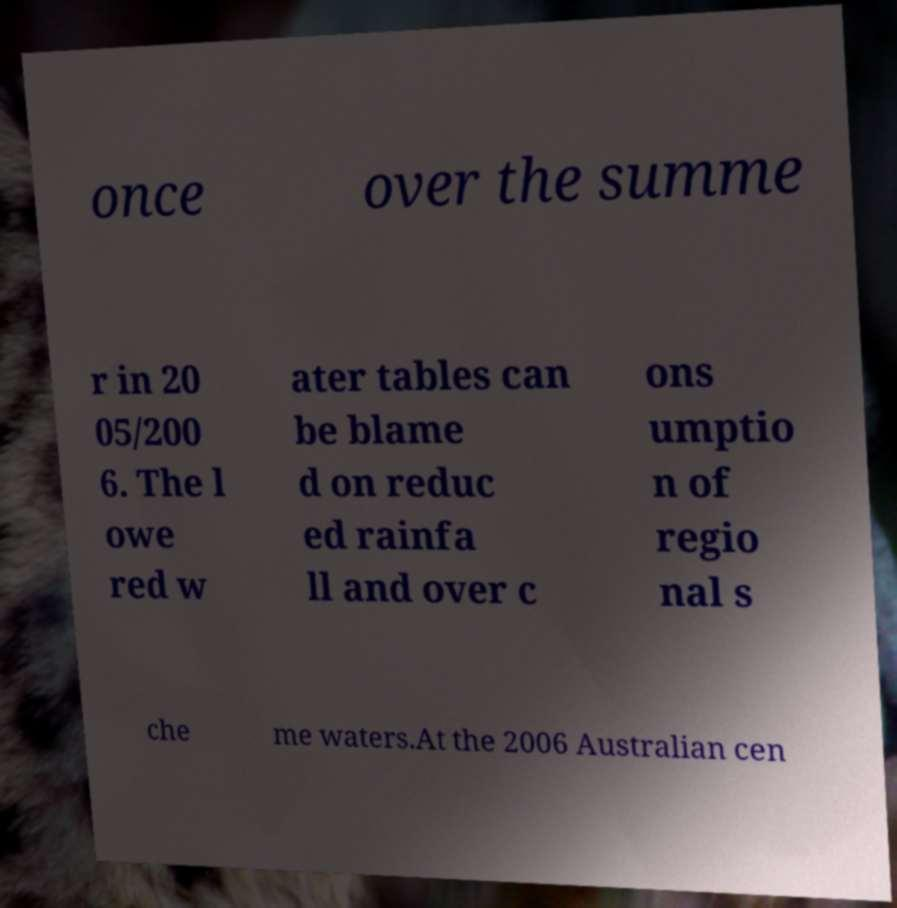Could you extract and type out the text from this image? once over the summe r in 20 05/200 6. The l owe red w ater tables can be blame d on reduc ed rainfa ll and over c ons umptio n of regio nal s che me waters.At the 2006 Australian cen 